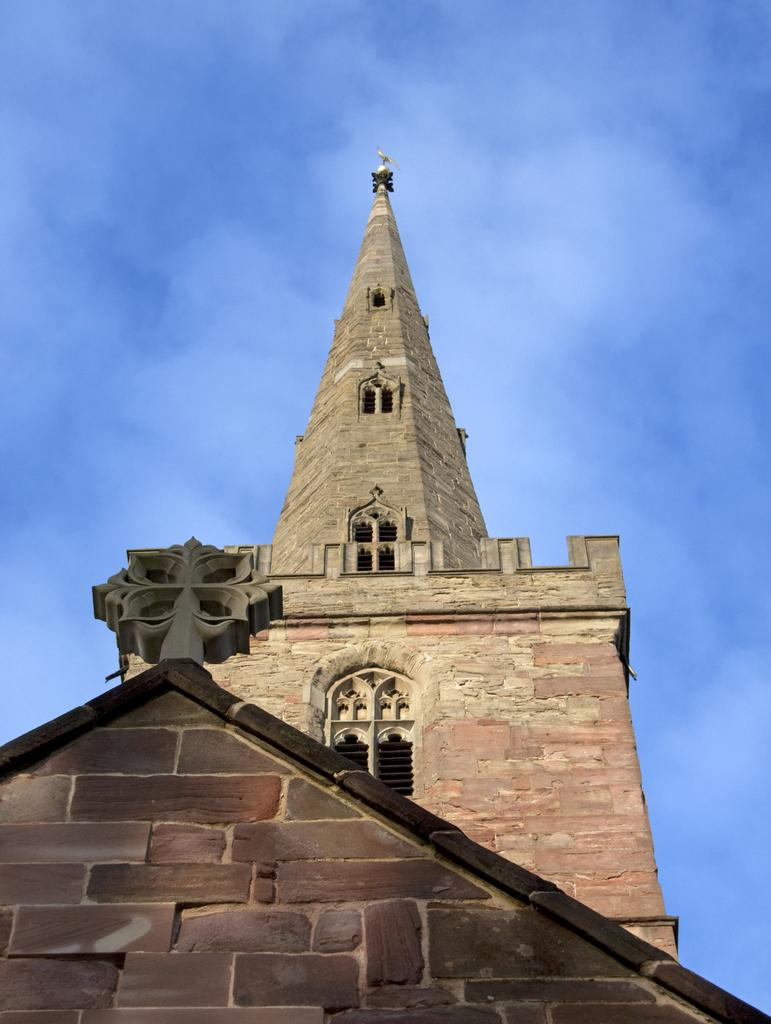What architectural feature can be seen in the image? There is a building spire in the image. What is the color of the sky in the image? The blue sky is visible at the top of the image. What type of beam is being used to support the building in the image? There is no beam visible in the image, and the support structure for the building is not mentioned in the facts. 